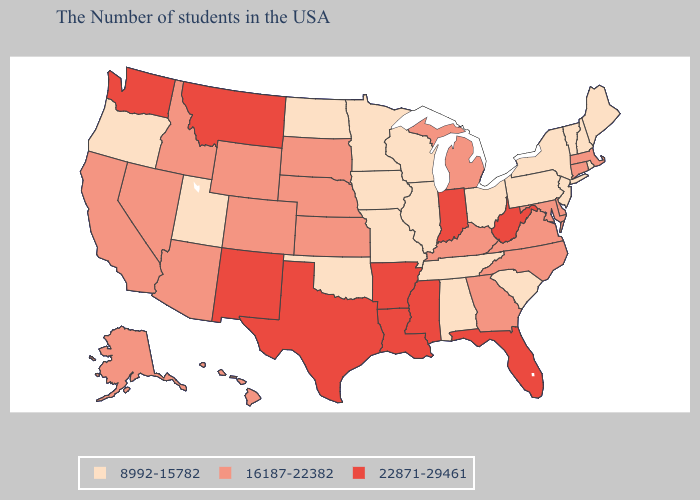Does the first symbol in the legend represent the smallest category?
Short answer required. Yes. Does Rhode Island have the highest value in the USA?
Concise answer only. No. Does Washington have the highest value in the West?
Answer briefly. Yes. Does Connecticut have a lower value than Nevada?
Concise answer only. No. Name the states that have a value in the range 8992-15782?
Short answer required. Maine, Rhode Island, New Hampshire, Vermont, New York, New Jersey, Pennsylvania, South Carolina, Ohio, Alabama, Tennessee, Wisconsin, Illinois, Missouri, Minnesota, Iowa, Oklahoma, North Dakota, Utah, Oregon. How many symbols are there in the legend?
Give a very brief answer. 3. Name the states that have a value in the range 22871-29461?
Short answer required. West Virginia, Florida, Indiana, Mississippi, Louisiana, Arkansas, Texas, New Mexico, Montana, Washington. Name the states that have a value in the range 8992-15782?
Answer briefly. Maine, Rhode Island, New Hampshire, Vermont, New York, New Jersey, Pennsylvania, South Carolina, Ohio, Alabama, Tennessee, Wisconsin, Illinois, Missouri, Minnesota, Iowa, Oklahoma, North Dakota, Utah, Oregon. What is the lowest value in states that border Connecticut?
Concise answer only. 8992-15782. Name the states that have a value in the range 22871-29461?
Write a very short answer. West Virginia, Florida, Indiana, Mississippi, Louisiana, Arkansas, Texas, New Mexico, Montana, Washington. Name the states that have a value in the range 22871-29461?
Keep it brief. West Virginia, Florida, Indiana, Mississippi, Louisiana, Arkansas, Texas, New Mexico, Montana, Washington. Does Texas have the highest value in the USA?
Short answer required. Yes. How many symbols are there in the legend?
Give a very brief answer. 3. Name the states that have a value in the range 16187-22382?
Give a very brief answer. Massachusetts, Connecticut, Delaware, Maryland, Virginia, North Carolina, Georgia, Michigan, Kentucky, Kansas, Nebraska, South Dakota, Wyoming, Colorado, Arizona, Idaho, Nevada, California, Alaska, Hawaii. What is the value of Kentucky?
Short answer required. 16187-22382. 